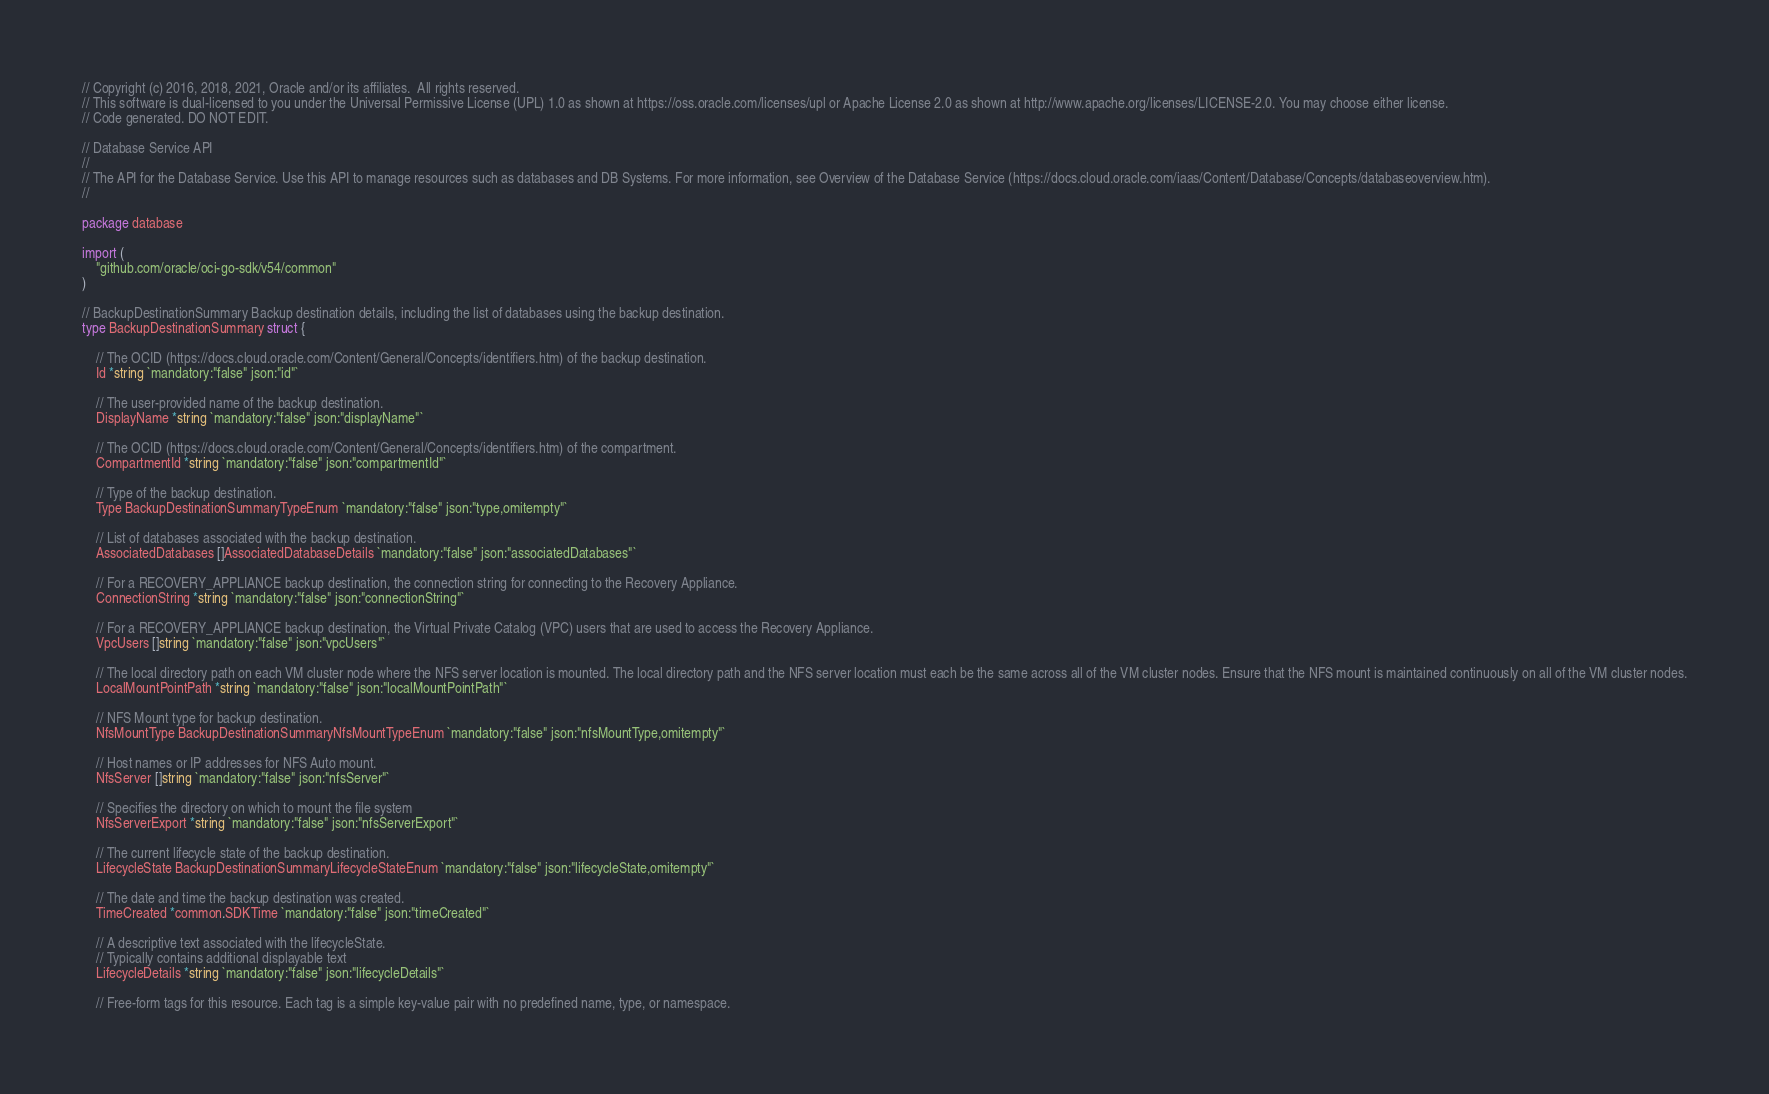Convert code to text. <code><loc_0><loc_0><loc_500><loc_500><_Go_>// Copyright (c) 2016, 2018, 2021, Oracle and/or its affiliates.  All rights reserved.
// This software is dual-licensed to you under the Universal Permissive License (UPL) 1.0 as shown at https://oss.oracle.com/licenses/upl or Apache License 2.0 as shown at http://www.apache.org/licenses/LICENSE-2.0. You may choose either license.
// Code generated. DO NOT EDIT.

// Database Service API
//
// The API for the Database Service. Use this API to manage resources such as databases and DB Systems. For more information, see Overview of the Database Service (https://docs.cloud.oracle.com/iaas/Content/Database/Concepts/databaseoverview.htm).
//

package database

import (
	"github.com/oracle/oci-go-sdk/v54/common"
)

// BackupDestinationSummary Backup destination details, including the list of databases using the backup destination.
type BackupDestinationSummary struct {

	// The OCID (https://docs.cloud.oracle.com/Content/General/Concepts/identifiers.htm) of the backup destination.
	Id *string `mandatory:"false" json:"id"`

	// The user-provided name of the backup destination.
	DisplayName *string `mandatory:"false" json:"displayName"`

	// The OCID (https://docs.cloud.oracle.com/Content/General/Concepts/identifiers.htm) of the compartment.
	CompartmentId *string `mandatory:"false" json:"compartmentId"`

	// Type of the backup destination.
	Type BackupDestinationSummaryTypeEnum `mandatory:"false" json:"type,omitempty"`

	// List of databases associated with the backup destination.
	AssociatedDatabases []AssociatedDatabaseDetails `mandatory:"false" json:"associatedDatabases"`

	// For a RECOVERY_APPLIANCE backup destination, the connection string for connecting to the Recovery Appliance.
	ConnectionString *string `mandatory:"false" json:"connectionString"`

	// For a RECOVERY_APPLIANCE backup destination, the Virtual Private Catalog (VPC) users that are used to access the Recovery Appliance.
	VpcUsers []string `mandatory:"false" json:"vpcUsers"`

	// The local directory path on each VM cluster node where the NFS server location is mounted. The local directory path and the NFS server location must each be the same across all of the VM cluster nodes. Ensure that the NFS mount is maintained continuously on all of the VM cluster nodes.
	LocalMountPointPath *string `mandatory:"false" json:"localMountPointPath"`

	// NFS Mount type for backup destination.
	NfsMountType BackupDestinationSummaryNfsMountTypeEnum `mandatory:"false" json:"nfsMountType,omitempty"`

	// Host names or IP addresses for NFS Auto mount.
	NfsServer []string `mandatory:"false" json:"nfsServer"`

	// Specifies the directory on which to mount the file system
	NfsServerExport *string `mandatory:"false" json:"nfsServerExport"`

	// The current lifecycle state of the backup destination.
	LifecycleState BackupDestinationSummaryLifecycleStateEnum `mandatory:"false" json:"lifecycleState,omitempty"`

	// The date and time the backup destination was created.
	TimeCreated *common.SDKTime `mandatory:"false" json:"timeCreated"`

	// A descriptive text associated with the lifecycleState.
	// Typically contains additional displayable text
	LifecycleDetails *string `mandatory:"false" json:"lifecycleDetails"`

	// Free-form tags for this resource. Each tag is a simple key-value pair with no predefined name, type, or namespace.</code> 